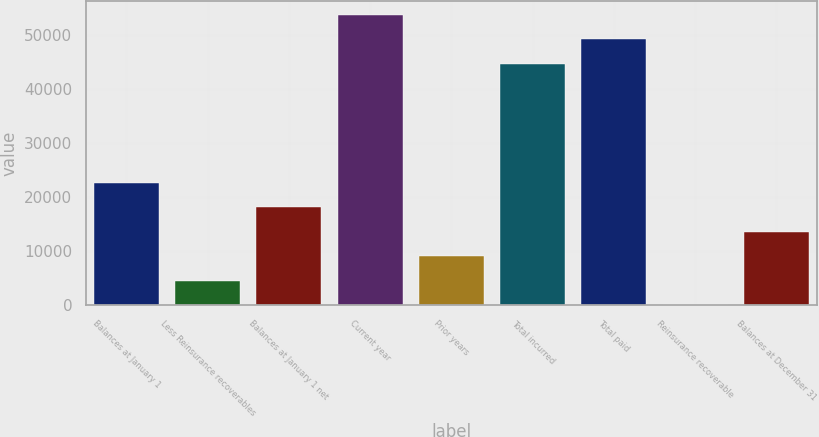<chart> <loc_0><loc_0><loc_500><loc_500><bar_chart><fcel>Balances at January 1<fcel>Less Reinsurance recoverables<fcel>Balances at January 1 net<fcel>Current year<fcel>Prior years<fcel>Total incurred<fcel>Total paid<fcel>Reinsurance recoverable<fcel>Balances at December 31<nl><fcel>22697<fcel>4600.2<fcel>18172.8<fcel>53784.4<fcel>9124.4<fcel>44736<fcel>49260.2<fcel>76<fcel>13648.6<nl></chart> 